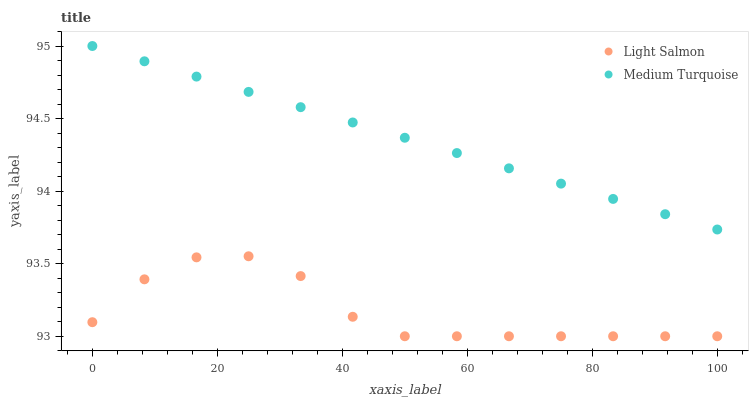Does Light Salmon have the minimum area under the curve?
Answer yes or no. Yes. Does Medium Turquoise have the maximum area under the curve?
Answer yes or no. Yes. Does Medium Turquoise have the minimum area under the curve?
Answer yes or no. No. Is Medium Turquoise the smoothest?
Answer yes or no. Yes. Is Light Salmon the roughest?
Answer yes or no. Yes. Is Medium Turquoise the roughest?
Answer yes or no. No. Does Light Salmon have the lowest value?
Answer yes or no. Yes. Does Medium Turquoise have the lowest value?
Answer yes or no. No. Does Medium Turquoise have the highest value?
Answer yes or no. Yes. Is Light Salmon less than Medium Turquoise?
Answer yes or no. Yes. Is Medium Turquoise greater than Light Salmon?
Answer yes or no. Yes. Does Light Salmon intersect Medium Turquoise?
Answer yes or no. No. 